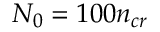Convert formula to latex. <formula><loc_0><loc_0><loc_500><loc_500>N _ { 0 } = 1 0 0 n _ { c r }</formula> 